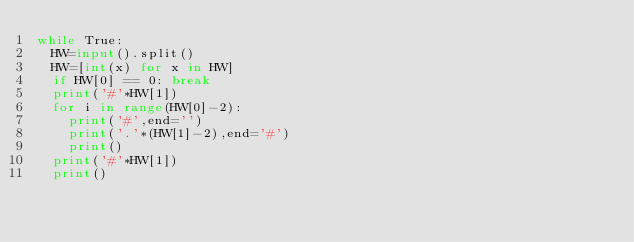<code> <loc_0><loc_0><loc_500><loc_500><_Python_>while True:
  HW=input().split()
  HW=[int(x) for x in HW]
  if HW[0] == 0: break
  print('#'*HW[1])
  for i in range(HW[0]-2):
    print('#',end='')
    print('.'*(HW[1]-2),end='#')
    print()
  print('#'*HW[1])
  print()</code> 